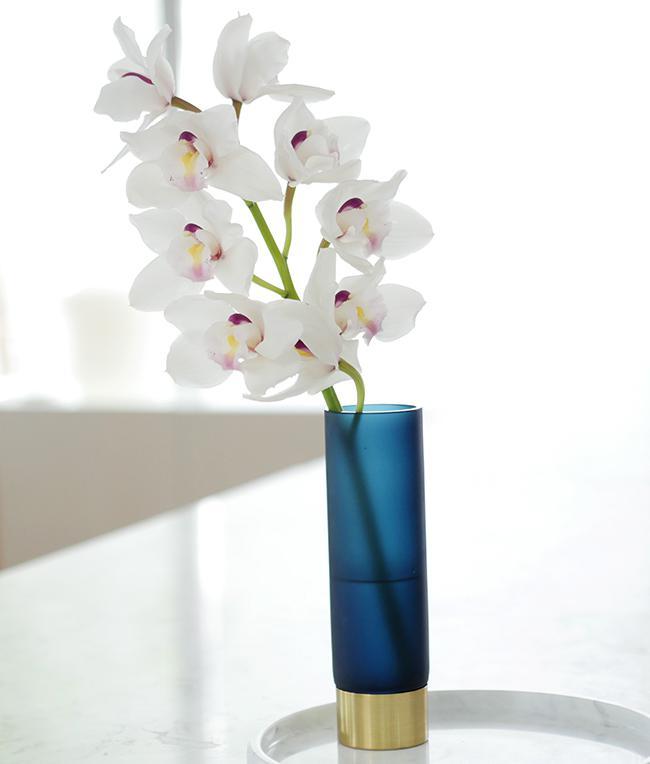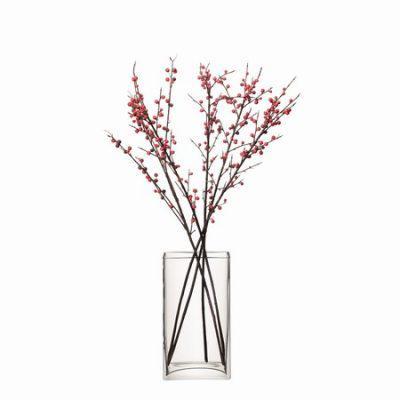The first image is the image on the left, the second image is the image on the right. Examine the images to the left and right. Is the description "The image on the left contains white flowers in a vase." accurate? Answer yes or no. Yes. 